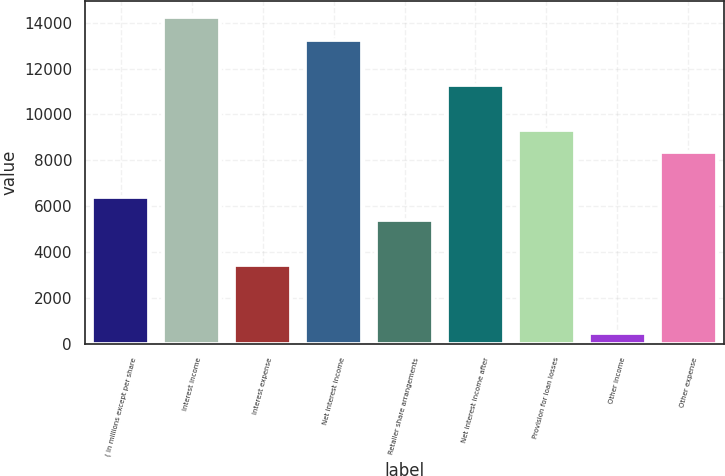<chart> <loc_0><loc_0><loc_500><loc_500><bar_chart><fcel>( in millions except per share<fcel>Interest income<fcel>Interest expense<fcel>Net interest income<fcel>Retailer share arrangements<fcel>Net interest income after<fcel>Provision for loan losses<fcel>Other income<fcel>Other expense<nl><fcel>6379<fcel>14239<fcel>3431.5<fcel>13256.5<fcel>5396.5<fcel>11291.5<fcel>9326.5<fcel>484<fcel>8344<nl></chart> 